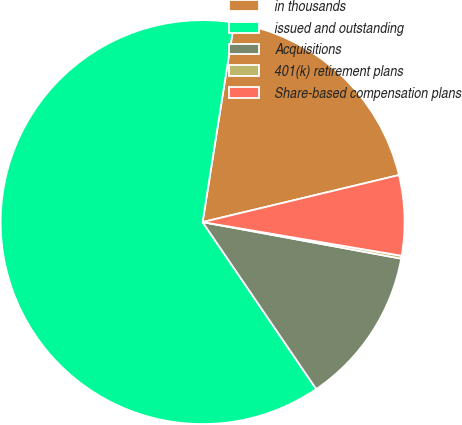<chart> <loc_0><loc_0><loc_500><loc_500><pie_chart><fcel>in thousands<fcel>issued and outstanding<fcel>Acquisitions<fcel>401(k) retirement plans<fcel>Share-based compensation plans<nl><fcel>18.76%<fcel>62.01%<fcel>12.59%<fcel>0.23%<fcel>6.41%<nl></chart> 